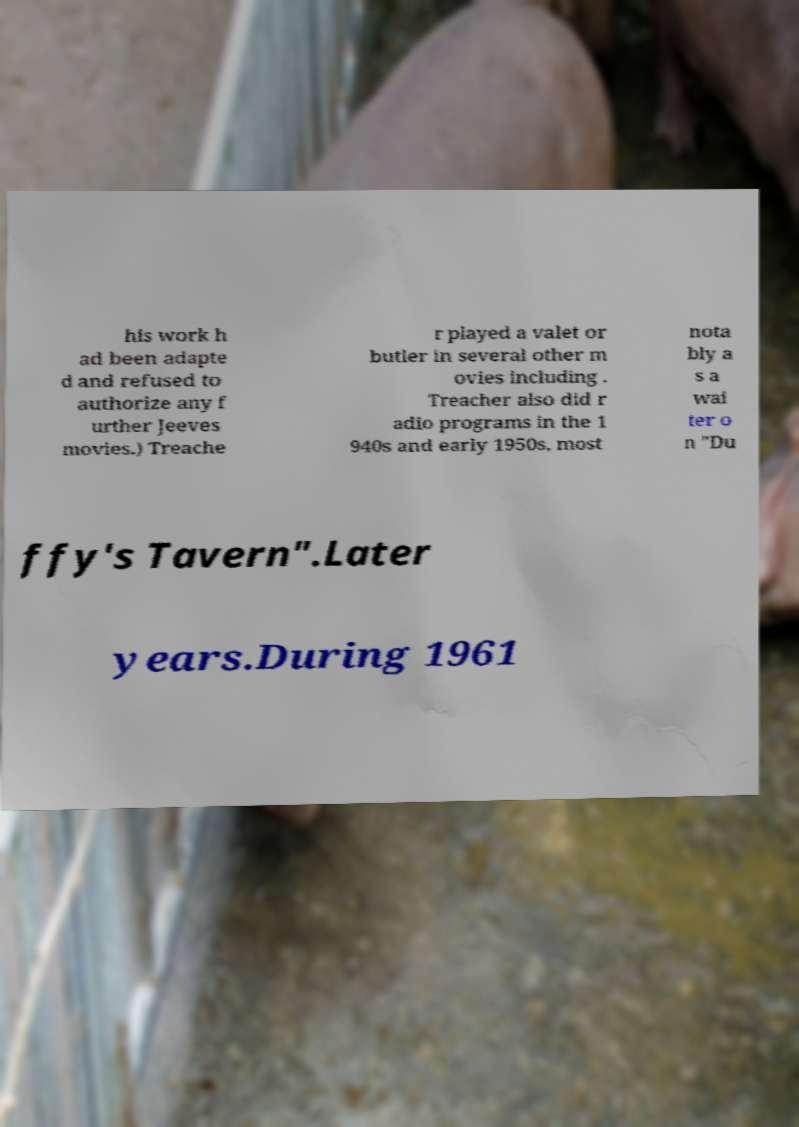Please identify and transcribe the text found in this image. his work h ad been adapte d and refused to authorize any f urther Jeeves movies.) Treache r played a valet or butler in several other m ovies including . Treacher also did r adio programs in the 1 940s and early 1950s, most nota bly a s a wai ter o n "Du ffy's Tavern".Later years.During 1961 